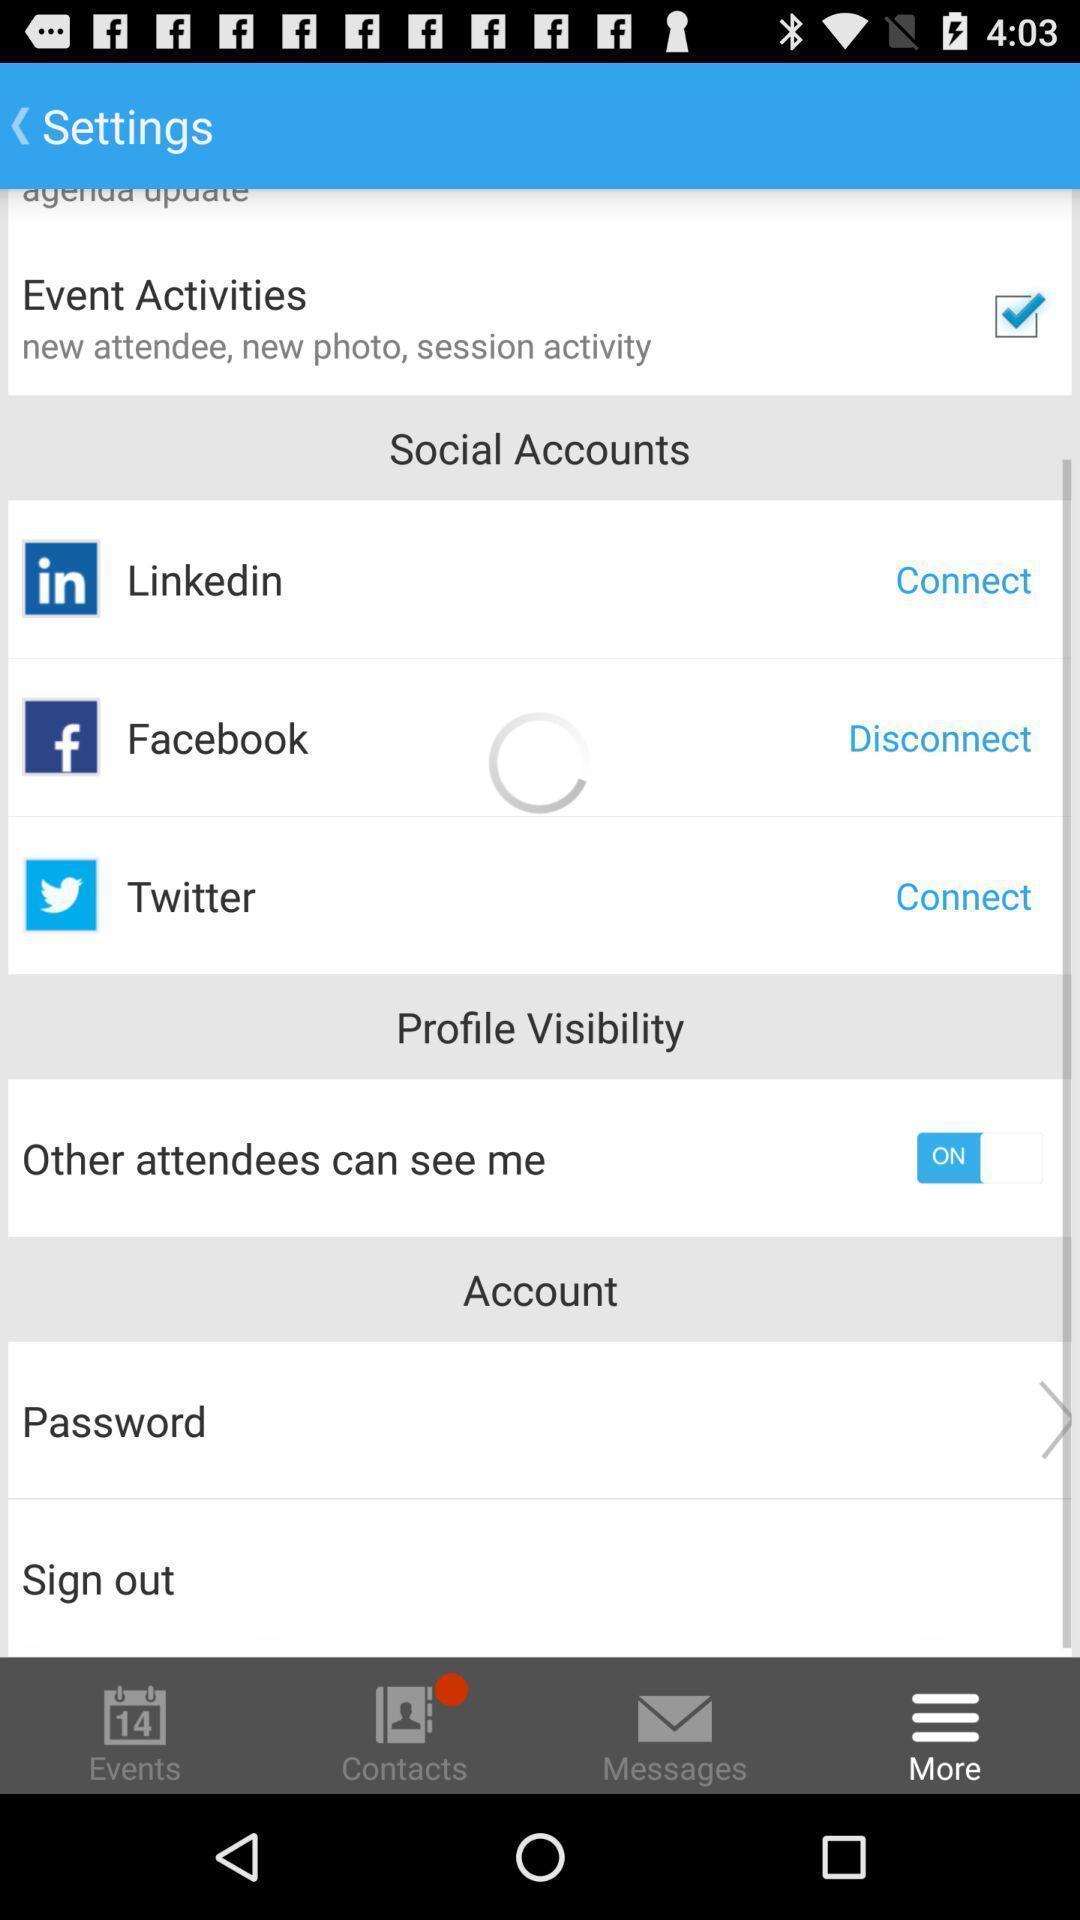Summarize the main components in this picture. Screen showing social accounts. 